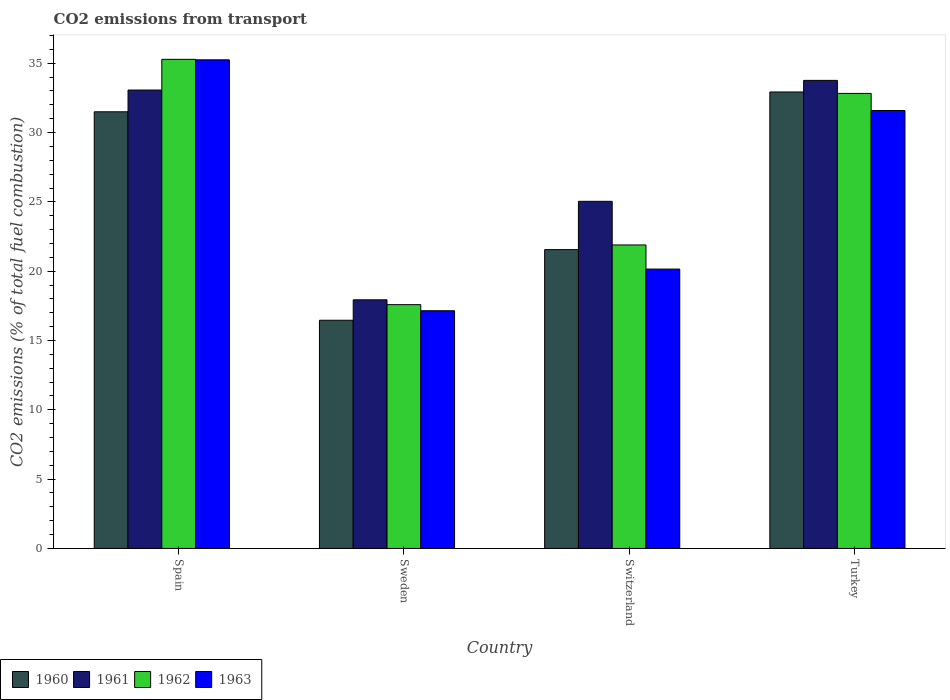How many different coloured bars are there?
Your answer should be compact. 4. How many groups of bars are there?
Offer a terse response. 4. How many bars are there on the 1st tick from the left?
Offer a very short reply. 4. How many bars are there on the 1st tick from the right?
Give a very brief answer. 4. What is the label of the 2nd group of bars from the left?
Offer a terse response. Sweden. In how many cases, is the number of bars for a given country not equal to the number of legend labels?
Keep it short and to the point. 0. What is the total CO2 emitted in 1962 in Sweden?
Ensure brevity in your answer.  17.59. Across all countries, what is the maximum total CO2 emitted in 1961?
Your answer should be compact. 33.76. Across all countries, what is the minimum total CO2 emitted in 1962?
Keep it short and to the point. 17.59. In which country was the total CO2 emitted in 1962 maximum?
Provide a short and direct response. Spain. In which country was the total CO2 emitted in 1963 minimum?
Offer a terse response. Sweden. What is the total total CO2 emitted in 1961 in the graph?
Give a very brief answer. 109.81. What is the difference between the total CO2 emitted in 1963 in Spain and that in Turkey?
Offer a very short reply. 3.66. What is the difference between the total CO2 emitted in 1962 in Switzerland and the total CO2 emitted in 1963 in Spain?
Your answer should be very brief. -13.36. What is the average total CO2 emitted in 1962 per country?
Your response must be concise. 26.9. What is the difference between the total CO2 emitted of/in 1962 and total CO2 emitted of/in 1961 in Switzerland?
Offer a very short reply. -3.15. In how many countries, is the total CO2 emitted in 1963 greater than 28?
Offer a terse response. 2. What is the ratio of the total CO2 emitted in 1963 in Sweden to that in Turkey?
Give a very brief answer. 0.54. What is the difference between the highest and the second highest total CO2 emitted in 1960?
Provide a short and direct response. 11.37. What is the difference between the highest and the lowest total CO2 emitted in 1962?
Your answer should be compact. 17.7. In how many countries, is the total CO2 emitted in 1961 greater than the average total CO2 emitted in 1961 taken over all countries?
Keep it short and to the point. 2. Is the sum of the total CO2 emitted in 1963 in Spain and Turkey greater than the maximum total CO2 emitted in 1960 across all countries?
Your answer should be compact. Yes. Is it the case that in every country, the sum of the total CO2 emitted in 1960 and total CO2 emitted in 1962 is greater than the sum of total CO2 emitted in 1961 and total CO2 emitted in 1963?
Your answer should be compact. No. What does the 2nd bar from the left in Turkey represents?
Offer a terse response. 1961. What does the 3rd bar from the right in Sweden represents?
Give a very brief answer. 1961. How many bars are there?
Offer a very short reply. 16. How many countries are there in the graph?
Keep it short and to the point. 4. What is the difference between two consecutive major ticks on the Y-axis?
Offer a very short reply. 5. Does the graph contain any zero values?
Keep it short and to the point. No. Where does the legend appear in the graph?
Offer a very short reply. Bottom left. What is the title of the graph?
Ensure brevity in your answer.  CO2 emissions from transport. Does "1983" appear as one of the legend labels in the graph?
Your answer should be compact. No. What is the label or title of the Y-axis?
Keep it short and to the point. CO2 emissions (% of total fuel combustion). What is the CO2 emissions (% of total fuel combustion) in 1960 in Spain?
Make the answer very short. 31.5. What is the CO2 emissions (% of total fuel combustion) in 1961 in Spain?
Give a very brief answer. 33.07. What is the CO2 emissions (% of total fuel combustion) of 1962 in Spain?
Make the answer very short. 35.28. What is the CO2 emissions (% of total fuel combustion) of 1963 in Spain?
Give a very brief answer. 35.25. What is the CO2 emissions (% of total fuel combustion) of 1960 in Sweden?
Give a very brief answer. 16.46. What is the CO2 emissions (% of total fuel combustion) of 1961 in Sweden?
Offer a very short reply. 17.94. What is the CO2 emissions (% of total fuel combustion) in 1962 in Sweden?
Your answer should be compact. 17.59. What is the CO2 emissions (% of total fuel combustion) of 1963 in Sweden?
Give a very brief answer. 17.15. What is the CO2 emissions (% of total fuel combustion) of 1960 in Switzerland?
Make the answer very short. 21.56. What is the CO2 emissions (% of total fuel combustion) in 1961 in Switzerland?
Your answer should be compact. 25.04. What is the CO2 emissions (% of total fuel combustion) of 1962 in Switzerland?
Offer a very short reply. 21.89. What is the CO2 emissions (% of total fuel combustion) in 1963 in Switzerland?
Provide a short and direct response. 20.15. What is the CO2 emissions (% of total fuel combustion) of 1960 in Turkey?
Ensure brevity in your answer.  32.93. What is the CO2 emissions (% of total fuel combustion) in 1961 in Turkey?
Your response must be concise. 33.76. What is the CO2 emissions (% of total fuel combustion) of 1962 in Turkey?
Ensure brevity in your answer.  32.82. What is the CO2 emissions (% of total fuel combustion) of 1963 in Turkey?
Your answer should be very brief. 31.59. Across all countries, what is the maximum CO2 emissions (% of total fuel combustion) in 1960?
Provide a succinct answer. 32.93. Across all countries, what is the maximum CO2 emissions (% of total fuel combustion) in 1961?
Keep it short and to the point. 33.76. Across all countries, what is the maximum CO2 emissions (% of total fuel combustion) in 1962?
Ensure brevity in your answer.  35.28. Across all countries, what is the maximum CO2 emissions (% of total fuel combustion) of 1963?
Give a very brief answer. 35.25. Across all countries, what is the minimum CO2 emissions (% of total fuel combustion) in 1960?
Keep it short and to the point. 16.46. Across all countries, what is the minimum CO2 emissions (% of total fuel combustion) of 1961?
Your response must be concise. 17.94. Across all countries, what is the minimum CO2 emissions (% of total fuel combustion) in 1962?
Offer a very short reply. 17.59. Across all countries, what is the minimum CO2 emissions (% of total fuel combustion) in 1963?
Offer a terse response. 17.15. What is the total CO2 emissions (% of total fuel combustion) in 1960 in the graph?
Your response must be concise. 102.45. What is the total CO2 emissions (% of total fuel combustion) of 1961 in the graph?
Your answer should be compact. 109.81. What is the total CO2 emissions (% of total fuel combustion) in 1962 in the graph?
Provide a succinct answer. 107.59. What is the total CO2 emissions (% of total fuel combustion) in 1963 in the graph?
Give a very brief answer. 104.14. What is the difference between the CO2 emissions (% of total fuel combustion) in 1960 in Spain and that in Sweden?
Offer a terse response. 15.04. What is the difference between the CO2 emissions (% of total fuel combustion) in 1961 in Spain and that in Sweden?
Offer a terse response. 15.13. What is the difference between the CO2 emissions (% of total fuel combustion) of 1962 in Spain and that in Sweden?
Provide a succinct answer. 17.7. What is the difference between the CO2 emissions (% of total fuel combustion) of 1963 in Spain and that in Sweden?
Your response must be concise. 18.1. What is the difference between the CO2 emissions (% of total fuel combustion) of 1960 in Spain and that in Switzerland?
Ensure brevity in your answer.  9.94. What is the difference between the CO2 emissions (% of total fuel combustion) of 1961 in Spain and that in Switzerland?
Provide a short and direct response. 8.03. What is the difference between the CO2 emissions (% of total fuel combustion) in 1962 in Spain and that in Switzerland?
Provide a succinct answer. 13.39. What is the difference between the CO2 emissions (% of total fuel combustion) in 1963 in Spain and that in Switzerland?
Provide a short and direct response. 15.1. What is the difference between the CO2 emissions (% of total fuel combustion) in 1960 in Spain and that in Turkey?
Give a very brief answer. -1.43. What is the difference between the CO2 emissions (% of total fuel combustion) of 1961 in Spain and that in Turkey?
Your answer should be very brief. -0.7. What is the difference between the CO2 emissions (% of total fuel combustion) in 1962 in Spain and that in Turkey?
Offer a terse response. 2.46. What is the difference between the CO2 emissions (% of total fuel combustion) of 1963 in Spain and that in Turkey?
Your answer should be compact. 3.66. What is the difference between the CO2 emissions (% of total fuel combustion) of 1960 in Sweden and that in Switzerland?
Provide a succinct answer. -5.09. What is the difference between the CO2 emissions (% of total fuel combustion) in 1961 in Sweden and that in Switzerland?
Your answer should be very brief. -7.1. What is the difference between the CO2 emissions (% of total fuel combustion) in 1962 in Sweden and that in Switzerland?
Keep it short and to the point. -4.31. What is the difference between the CO2 emissions (% of total fuel combustion) of 1963 in Sweden and that in Switzerland?
Ensure brevity in your answer.  -3.01. What is the difference between the CO2 emissions (% of total fuel combustion) in 1960 in Sweden and that in Turkey?
Give a very brief answer. -16.47. What is the difference between the CO2 emissions (% of total fuel combustion) in 1961 in Sweden and that in Turkey?
Offer a terse response. -15.83. What is the difference between the CO2 emissions (% of total fuel combustion) in 1962 in Sweden and that in Turkey?
Your answer should be very brief. -15.24. What is the difference between the CO2 emissions (% of total fuel combustion) of 1963 in Sweden and that in Turkey?
Make the answer very short. -14.44. What is the difference between the CO2 emissions (% of total fuel combustion) of 1960 in Switzerland and that in Turkey?
Make the answer very short. -11.37. What is the difference between the CO2 emissions (% of total fuel combustion) in 1961 in Switzerland and that in Turkey?
Provide a short and direct response. -8.72. What is the difference between the CO2 emissions (% of total fuel combustion) of 1962 in Switzerland and that in Turkey?
Make the answer very short. -10.93. What is the difference between the CO2 emissions (% of total fuel combustion) of 1963 in Switzerland and that in Turkey?
Provide a short and direct response. -11.44. What is the difference between the CO2 emissions (% of total fuel combustion) of 1960 in Spain and the CO2 emissions (% of total fuel combustion) of 1961 in Sweden?
Provide a short and direct response. 13.56. What is the difference between the CO2 emissions (% of total fuel combustion) in 1960 in Spain and the CO2 emissions (% of total fuel combustion) in 1962 in Sweden?
Provide a succinct answer. 13.91. What is the difference between the CO2 emissions (% of total fuel combustion) of 1960 in Spain and the CO2 emissions (% of total fuel combustion) of 1963 in Sweden?
Offer a very short reply. 14.35. What is the difference between the CO2 emissions (% of total fuel combustion) in 1961 in Spain and the CO2 emissions (% of total fuel combustion) in 1962 in Sweden?
Make the answer very short. 15.48. What is the difference between the CO2 emissions (% of total fuel combustion) of 1961 in Spain and the CO2 emissions (% of total fuel combustion) of 1963 in Sweden?
Give a very brief answer. 15.92. What is the difference between the CO2 emissions (% of total fuel combustion) in 1962 in Spain and the CO2 emissions (% of total fuel combustion) in 1963 in Sweden?
Provide a succinct answer. 18.14. What is the difference between the CO2 emissions (% of total fuel combustion) in 1960 in Spain and the CO2 emissions (% of total fuel combustion) in 1961 in Switzerland?
Keep it short and to the point. 6.46. What is the difference between the CO2 emissions (% of total fuel combustion) in 1960 in Spain and the CO2 emissions (% of total fuel combustion) in 1962 in Switzerland?
Offer a very short reply. 9.61. What is the difference between the CO2 emissions (% of total fuel combustion) of 1960 in Spain and the CO2 emissions (% of total fuel combustion) of 1963 in Switzerland?
Keep it short and to the point. 11.35. What is the difference between the CO2 emissions (% of total fuel combustion) in 1961 in Spain and the CO2 emissions (% of total fuel combustion) in 1962 in Switzerland?
Offer a terse response. 11.17. What is the difference between the CO2 emissions (% of total fuel combustion) in 1961 in Spain and the CO2 emissions (% of total fuel combustion) in 1963 in Switzerland?
Provide a succinct answer. 12.92. What is the difference between the CO2 emissions (% of total fuel combustion) in 1962 in Spain and the CO2 emissions (% of total fuel combustion) in 1963 in Switzerland?
Give a very brief answer. 15.13. What is the difference between the CO2 emissions (% of total fuel combustion) of 1960 in Spain and the CO2 emissions (% of total fuel combustion) of 1961 in Turkey?
Give a very brief answer. -2.27. What is the difference between the CO2 emissions (% of total fuel combustion) of 1960 in Spain and the CO2 emissions (% of total fuel combustion) of 1962 in Turkey?
Offer a very short reply. -1.33. What is the difference between the CO2 emissions (% of total fuel combustion) of 1960 in Spain and the CO2 emissions (% of total fuel combustion) of 1963 in Turkey?
Provide a short and direct response. -0.09. What is the difference between the CO2 emissions (% of total fuel combustion) of 1961 in Spain and the CO2 emissions (% of total fuel combustion) of 1962 in Turkey?
Provide a succinct answer. 0.24. What is the difference between the CO2 emissions (% of total fuel combustion) in 1961 in Spain and the CO2 emissions (% of total fuel combustion) in 1963 in Turkey?
Offer a terse response. 1.48. What is the difference between the CO2 emissions (% of total fuel combustion) in 1962 in Spain and the CO2 emissions (% of total fuel combustion) in 1963 in Turkey?
Offer a very short reply. 3.69. What is the difference between the CO2 emissions (% of total fuel combustion) in 1960 in Sweden and the CO2 emissions (% of total fuel combustion) in 1961 in Switzerland?
Give a very brief answer. -8.58. What is the difference between the CO2 emissions (% of total fuel combustion) in 1960 in Sweden and the CO2 emissions (% of total fuel combustion) in 1962 in Switzerland?
Your answer should be compact. -5.43. What is the difference between the CO2 emissions (% of total fuel combustion) of 1960 in Sweden and the CO2 emissions (% of total fuel combustion) of 1963 in Switzerland?
Your answer should be very brief. -3.69. What is the difference between the CO2 emissions (% of total fuel combustion) of 1961 in Sweden and the CO2 emissions (% of total fuel combustion) of 1962 in Switzerland?
Offer a very short reply. -3.96. What is the difference between the CO2 emissions (% of total fuel combustion) of 1961 in Sweden and the CO2 emissions (% of total fuel combustion) of 1963 in Switzerland?
Offer a very short reply. -2.22. What is the difference between the CO2 emissions (% of total fuel combustion) of 1962 in Sweden and the CO2 emissions (% of total fuel combustion) of 1963 in Switzerland?
Your answer should be very brief. -2.57. What is the difference between the CO2 emissions (% of total fuel combustion) in 1960 in Sweden and the CO2 emissions (% of total fuel combustion) in 1961 in Turkey?
Provide a succinct answer. -17.3. What is the difference between the CO2 emissions (% of total fuel combustion) in 1960 in Sweden and the CO2 emissions (% of total fuel combustion) in 1962 in Turkey?
Your response must be concise. -16.36. What is the difference between the CO2 emissions (% of total fuel combustion) of 1960 in Sweden and the CO2 emissions (% of total fuel combustion) of 1963 in Turkey?
Make the answer very short. -15.13. What is the difference between the CO2 emissions (% of total fuel combustion) in 1961 in Sweden and the CO2 emissions (% of total fuel combustion) in 1962 in Turkey?
Your response must be concise. -14.89. What is the difference between the CO2 emissions (% of total fuel combustion) in 1961 in Sweden and the CO2 emissions (% of total fuel combustion) in 1963 in Turkey?
Your answer should be very brief. -13.66. What is the difference between the CO2 emissions (% of total fuel combustion) of 1962 in Sweden and the CO2 emissions (% of total fuel combustion) of 1963 in Turkey?
Offer a very short reply. -14.01. What is the difference between the CO2 emissions (% of total fuel combustion) in 1960 in Switzerland and the CO2 emissions (% of total fuel combustion) in 1961 in Turkey?
Your response must be concise. -12.21. What is the difference between the CO2 emissions (% of total fuel combustion) of 1960 in Switzerland and the CO2 emissions (% of total fuel combustion) of 1962 in Turkey?
Keep it short and to the point. -11.27. What is the difference between the CO2 emissions (% of total fuel combustion) of 1960 in Switzerland and the CO2 emissions (% of total fuel combustion) of 1963 in Turkey?
Provide a short and direct response. -10.04. What is the difference between the CO2 emissions (% of total fuel combustion) in 1961 in Switzerland and the CO2 emissions (% of total fuel combustion) in 1962 in Turkey?
Give a very brief answer. -7.78. What is the difference between the CO2 emissions (% of total fuel combustion) in 1961 in Switzerland and the CO2 emissions (% of total fuel combustion) in 1963 in Turkey?
Offer a terse response. -6.55. What is the difference between the CO2 emissions (% of total fuel combustion) in 1962 in Switzerland and the CO2 emissions (% of total fuel combustion) in 1963 in Turkey?
Make the answer very short. -9.7. What is the average CO2 emissions (% of total fuel combustion) of 1960 per country?
Offer a terse response. 25.61. What is the average CO2 emissions (% of total fuel combustion) in 1961 per country?
Ensure brevity in your answer.  27.45. What is the average CO2 emissions (% of total fuel combustion) of 1962 per country?
Provide a short and direct response. 26.9. What is the average CO2 emissions (% of total fuel combustion) of 1963 per country?
Ensure brevity in your answer.  26.03. What is the difference between the CO2 emissions (% of total fuel combustion) of 1960 and CO2 emissions (% of total fuel combustion) of 1961 in Spain?
Offer a very short reply. -1.57. What is the difference between the CO2 emissions (% of total fuel combustion) of 1960 and CO2 emissions (% of total fuel combustion) of 1962 in Spain?
Make the answer very short. -3.78. What is the difference between the CO2 emissions (% of total fuel combustion) in 1960 and CO2 emissions (% of total fuel combustion) in 1963 in Spain?
Provide a succinct answer. -3.75. What is the difference between the CO2 emissions (% of total fuel combustion) in 1961 and CO2 emissions (% of total fuel combustion) in 1962 in Spain?
Make the answer very short. -2.22. What is the difference between the CO2 emissions (% of total fuel combustion) of 1961 and CO2 emissions (% of total fuel combustion) of 1963 in Spain?
Keep it short and to the point. -2.18. What is the difference between the CO2 emissions (% of total fuel combustion) in 1962 and CO2 emissions (% of total fuel combustion) in 1963 in Spain?
Ensure brevity in your answer.  0.04. What is the difference between the CO2 emissions (% of total fuel combustion) in 1960 and CO2 emissions (% of total fuel combustion) in 1961 in Sweden?
Your response must be concise. -1.47. What is the difference between the CO2 emissions (% of total fuel combustion) of 1960 and CO2 emissions (% of total fuel combustion) of 1962 in Sweden?
Give a very brief answer. -1.12. What is the difference between the CO2 emissions (% of total fuel combustion) of 1960 and CO2 emissions (% of total fuel combustion) of 1963 in Sweden?
Give a very brief answer. -0.69. What is the difference between the CO2 emissions (% of total fuel combustion) of 1961 and CO2 emissions (% of total fuel combustion) of 1962 in Sweden?
Offer a very short reply. 0.35. What is the difference between the CO2 emissions (% of total fuel combustion) in 1961 and CO2 emissions (% of total fuel combustion) in 1963 in Sweden?
Provide a succinct answer. 0.79. What is the difference between the CO2 emissions (% of total fuel combustion) in 1962 and CO2 emissions (% of total fuel combustion) in 1963 in Sweden?
Offer a very short reply. 0.44. What is the difference between the CO2 emissions (% of total fuel combustion) in 1960 and CO2 emissions (% of total fuel combustion) in 1961 in Switzerland?
Your answer should be very brief. -3.48. What is the difference between the CO2 emissions (% of total fuel combustion) of 1960 and CO2 emissions (% of total fuel combustion) of 1962 in Switzerland?
Offer a very short reply. -0.34. What is the difference between the CO2 emissions (% of total fuel combustion) of 1960 and CO2 emissions (% of total fuel combustion) of 1963 in Switzerland?
Ensure brevity in your answer.  1.4. What is the difference between the CO2 emissions (% of total fuel combustion) in 1961 and CO2 emissions (% of total fuel combustion) in 1962 in Switzerland?
Your answer should be very brief. 3.15. What is the difference between the CO2 emissions (% of total fuel combustion) of 1961 and CO2 emissions (% of total fuel combustion) of 1963 in Switzerland?
Give a very brief answer. 4.89. What is the difference between the CO2 emissions (% of total fuel combustion) of 1962 and CO2 emissions (% of total fuel combustion) of 1963 in Switzerland?
Your answer should be compact. 1.74. What is the difference between the CO2 emissions (% of total fuel combustion) in 1960 and CO2 emissions (% of total fuel combustion) in 1961 in Turkey?
Your answer should be compact. -0.84. What is the difference between the CO2 emissions (% of total fuel combustion) in 1960 and CO2 emissions (% of total fuel combustion) in 1962 in Turkey?
Provide a succinct answer. 0.1. What is the difference between the CO2 emissions (% of total fuel combustion) in 1960 and CO2 emissions (% of total fuel combustion) in 1963 in Turkey?
Your response must be concise. 1.34. What is the difference between the CO2 emissions (% of total fuel combustion) in 1961 and CO2 emissions (% of total fuel combustion) in 1962 in Turkey?
Give a very brief answer. 0.94. What is the difference between the CO2 emissions (% of total fuel combustion) in 1961 and CO2 emissions (% of total fuel combustion) in 1963 in Turkey?
Your answer should be very brief. 2.17. What is the difference between the CO2 emissions (% of total fuel combustion) in 1962 and CO2 emissions (% of total fuel combustion) in 1963 in Turkey?
Provide a short and direct response. 1.23. What is the ratio of the CO2 emissions (% of total fuel combustion) in 1960 in Spain to that in Sweden?
Offer a very short reply. 1.91. What is the ratio of the CO2 emissions (% of total fuel combustion) of 1961 in Spain to that in Sweden?
Offer a very short reply. 1.84. What is the ratio of the CO2 emissions (% of total fuel combustion) of 1962 in Spain to that in Sweden?
Ensure brevity in your answer.  2.01. What is the ratio of the CO2 emissions (% of total fuel combustion) in 1963 in Spain to that in Sweden?
Provide a short and direct response. 2.06. What is the ratio of the CO2 emissions (% of total fuel combustion) in 1960 in Spain to that in Switzerland?
Provide a short and direct response. 1.46. What is the ratio of the CO2 emissions (% of total fuel combustion) of 1961 in Spain to that in Switzerland?
Keep it short and to the point. 1.32. What is the ratio of the CO2 emissions (% of total fuel combustion) in 1962 in Spain to that in Switzerland?
Offer a very short reply. 1.61. What is the ratio of the CO2 emissions (% of total fuel combustion) of 1963 in Spain to that in Switzerland?
Offer a terse response. 1.75. What is the ratio of the CO2 emissions (% of total fuel combustion) in 1960 in Spain to that in Turkey?
Your answer should be compact. 0.96. What is the ratio of the CO2 emissions (% of total fuel combustion) in 1961 in Spain to that in Turkey?
Give a very brief answer. 0.98. What is the ratio of the CO2 emissions (% of total fuel combustion) in 1962 in Spain to that in Turkey?
Make the answer very short. 1.07. What is the ratio of the CO2 emissions (% of total fuel combustion) in 1963 in Spain to that in Turkey?
Give a very brief answer. 1.12. What is the ratio of the CO2 emissions (% of total fuel combustion) in 1960 in Sweden to that in Switzerland?
Offer a terse response. 0.76. What is the ratio of the CO2 emissions (% of total fuel combustion) in 1961 in Sweden to that in Switzerland?
Offer a very short reply. 0.72. What is the ratio of the CO2 emissions (% of total fuel combustion) in 1962 in Sweden to that in Switzerland?
Your response must be concise. 0.8. What is the ratio of the CO2 emissions (% of total fuel combustion) in 1963 in Sweden to that in Switzerland?
Keep it short and to the point. 0.85. What is the ratio of the CO2 emissions (% of total fuel combustion) in 1960 in Sweden to that in Turkey?
Your response must be concise. 0.5. What is the ratio of the CO2 emissions (% of total fuel combustion) in 1961 in Sweden to that in Turkey?
Give a very brief answer. 0.53. What is the ratio of the CO2 emissions (% of total fuel combustion) of 1962 in Sweden to that in Turkey?
Keep it short and to the point. 0.54. What is the ratio of the CO2 emissions (% of total fuel combustion) in 1963 in Sweden to that in Turkey?
Give a very brief answer. 0.54. What is the ratio of the CO2 emissions (% of total fuel combustion) in 1960 in Switzerland to that in Turkey?
Keep it short and to the point. 0.65. What is the ratio of the CO2 emissions (% of total fuel combustion) of 1961 in Switzerland to that in Turkey?
Your answer should be very brief. 0.74. What is the ratio of the CO2 emissions (% of total fuel combustion) in 1962 in Switzerland to that in Turkey?
Keep it short and to the point. 0.67. What is the ratio of the CO2 emissions (% of total fuel combustion) in 1963 in Switzerland to that in Turkey?
Keep it short and to the point. 0.64. What is the difference between the highest and the second highest CO2 emissions (% of total fuel combustion) in 1960?
Provide a succinct answer. 1.43. What is the difference between the highest and the second highest CO2 emissions (% of total fuel combustion) in 1961?
Keep it short and to the point. 0.7. What is the difference between the highest and the second highest CO2 emissions (% of total fuel combustion) in 1962?
Give a very brief answer. 2.46. What is the difference between the highest and the second highest CO2 emissions (% of total fuel combustion) in 1963?
Offer a very short reply. 3.66. What is the difference between the highest and the lowest CO2 emissions (% of total fuel combustion) in 1960?
Make the answer very short. 16.47. What is the difference between the highest and the lowest CO2 emissions (% of total fuel combustion) of 1961?
Offer a terse response. 15.83. What is the difference between the highest and the lowest CO2 emissions (% of total fuel combustion) of 1962?
Ensure brevity in your answer.  17.7. What is the difference between the highest and the lowest CO2 emissions (% of total fuel combustion) of 1963?
Keep it short and to the point. 18.1. 